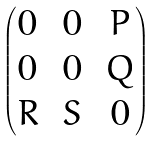<formula> <loc_0><loc_0><loc_500><loc_500>\begin{pmatrix} 0 \, & 0 \, & P \\ 0 \, & 0 \, & Q \\ R \, & S \, & 0 \end{pmatrix}</formula> 